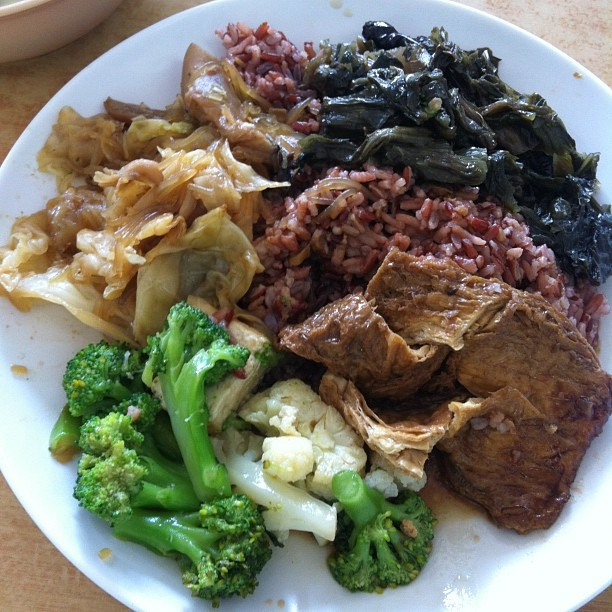Describe the objects in this image and their specific colors. I can see broccoli in darkgray, darkgreen, and green tones and broccoli in darkgray, darkgreen, black, and green tones in this image. 